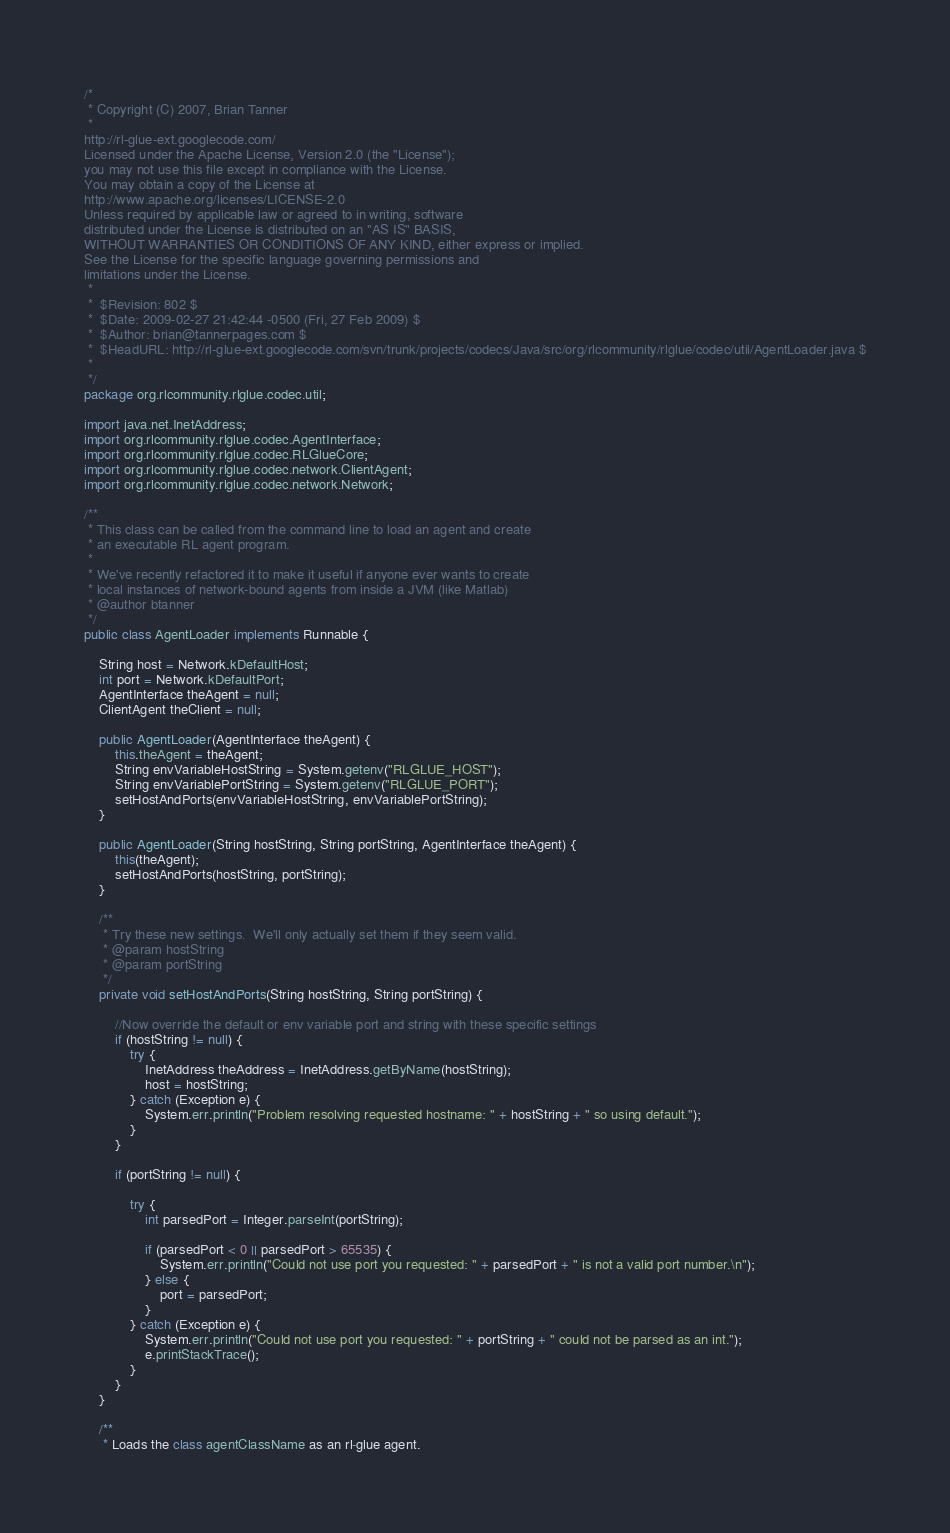<code> <loc_0><loc_0><loc_500><loc_500><_Java_>/* 
 * Copyright (C) 2007, Brian Tanner
 * 
http://rl-glue-ext.googlecode.com/
Licensed under the Apache License, Version 2.0 (the "License");
you may not use this file except in compliance with the License.
You may obtain a copy of the License at
http://www.apache.org/licenses/LICENSE-2.0
Unless required by applicable law or agreed to in writing, software
distributed under the License is distributed on an "AS IS" BASIS,
WITHOUT WARRANTIES OR CONDITIONS OF ANY KIND, either express or implied.
See the License for the specific language governing permissions and
limitations under the License.
 * 
 *  $Revision: 802 $
 *  $Date: 2009-02-27 21:42:44 -0500 (Fri, 27 Feb 2009) $
 *  $Author: brian@tannerpages.com $
 *  $HeadURL: http://rl-glue-ext.googlecode.com/svn/trunk/projects/codecs/Java/src/org/rlcommunity/rlglue/codec/util/AgentLoader.java $
 * 
 */
package org.rlcommunity.rlglue.codec.util;

import java.net.InetAddress;
import org.rlcommunity.rlglue.codec.AgentInterface;
import org.rlcommunity.rlglue.codec.RLGlueCore;
import org.rlcommunity.rlglue.codec.network.ClientAgent;
import org.rlcommunity.rlglue.codec.network.Network;

/**
 * This class can be called from the command line to load an agent and create
 * an executable RL agent program.  
 * 
 * We've recently refactored it to make it useful if anyone ever wants to create
 * local instances of network-bound agents from inside a JVM (like Matlab)
 * @author btanner
 */
public class AgentLoader implements Runnable {

    String host = Network.kDefaultHost;
    int port = Network.kDefaultPort;
    AgentInterface theAgent = null;
    ClientAgent theClient = null;

    public AgentLoader(AgentInterface theAgent) {
        this.theAgent = theAgent;
        String envVariableHostString = System.getenv("RLGLUE_HOST");
        String envVariablePortString = System.getenv("RLGLUE_PORT");
        setHostAndPorts(envVariableHostString, envVariablePortString);
    }

    public AgentLoader(String hostString, String portString, AgentInterface theAgent) {
        this(theAgent);
        setHostAndPorts(hostString, portString);
    }

    /**
     * Try these new settings.  We'll only actually set them if they seem valid.
     * @param hostString
     * @param portString
     */
    private void setHostAndPorts(String hostString, String portString) {

        //Now override the default or env variable port and string with these specific settings
        if (hostString != null) {
            try {
                InetAddress theAddress = InetAddress.getByName(hostString);
                host = hostString;
            } catch (Exception e) {
                System.err.println("Problem resolving requested hostname: " + hostString + " so using default.");
            }
        }

        if (portString != null) {

            try {
                int parsedPort = Integer.parseInt(portString);

                if (parsedPort < 0 || parsedPort > 65535) {
                    System.err.println("Could not use port you requested: " + parsedPort + " is not a valid port number.\n");
                } else {
                    port = parsedPort;
                }
            } catch (Exception e) {
                System.err.println("Could not use port you requested: " + portString + " could not be parsed as an int.");
                e.printStackTrace();
            }
        }
    }

    /**
     * Loads the class agentClassName as an rl-glue agent.</code> 